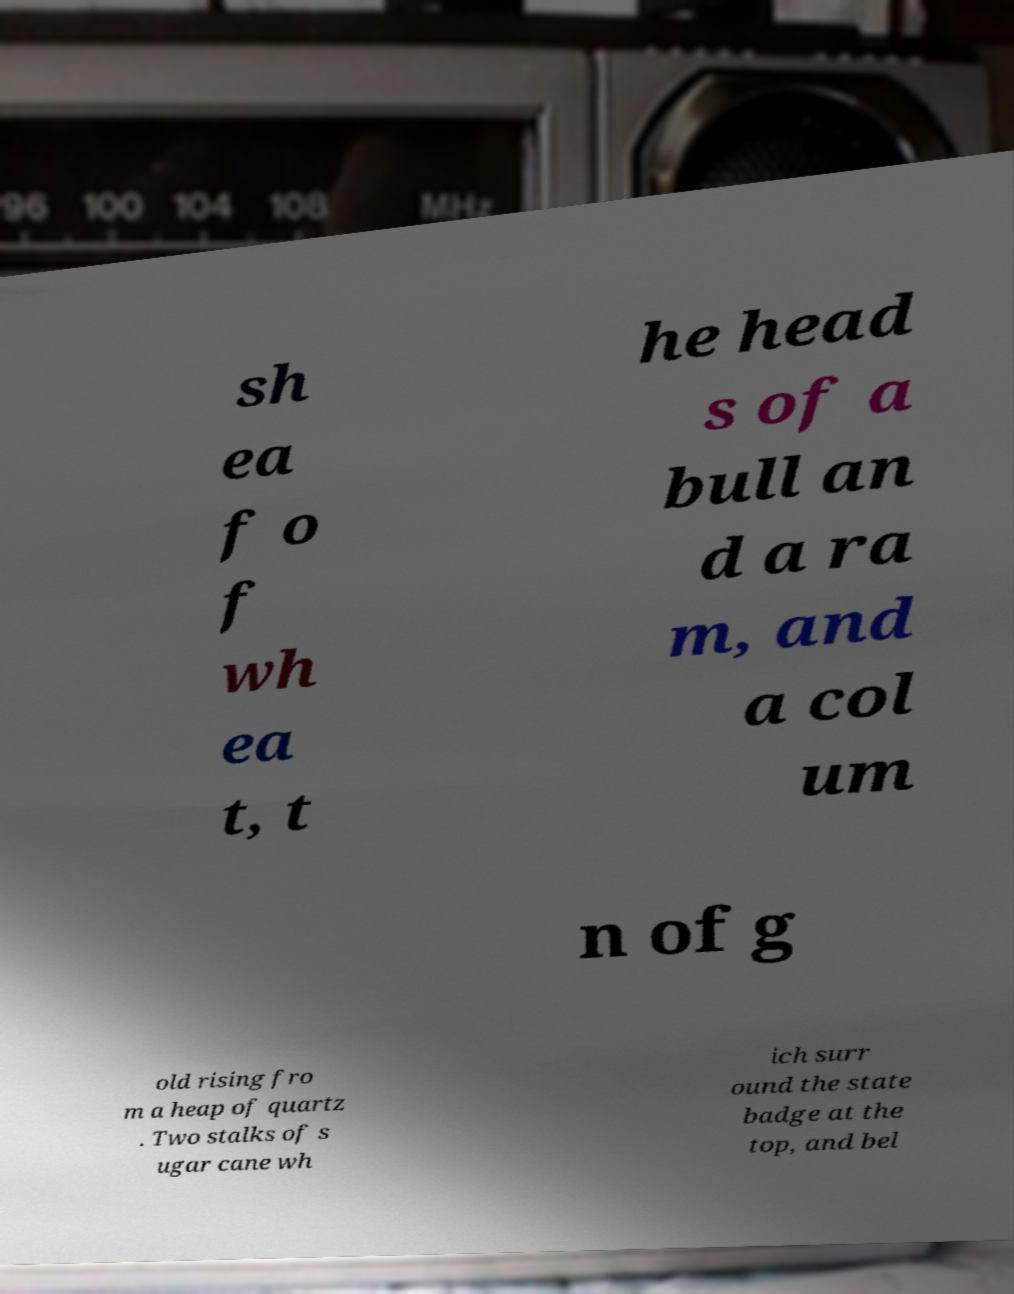Could you assist in decoding the text presented in this image and type it out clearly? sh ea f o f wh ea t, t he head s of a bull an d a ra m, and a col um n of g old rising fro m a heap of quartz . Two stalks of s ugar cane wh ich surr ound the state badge at the top, and bel 